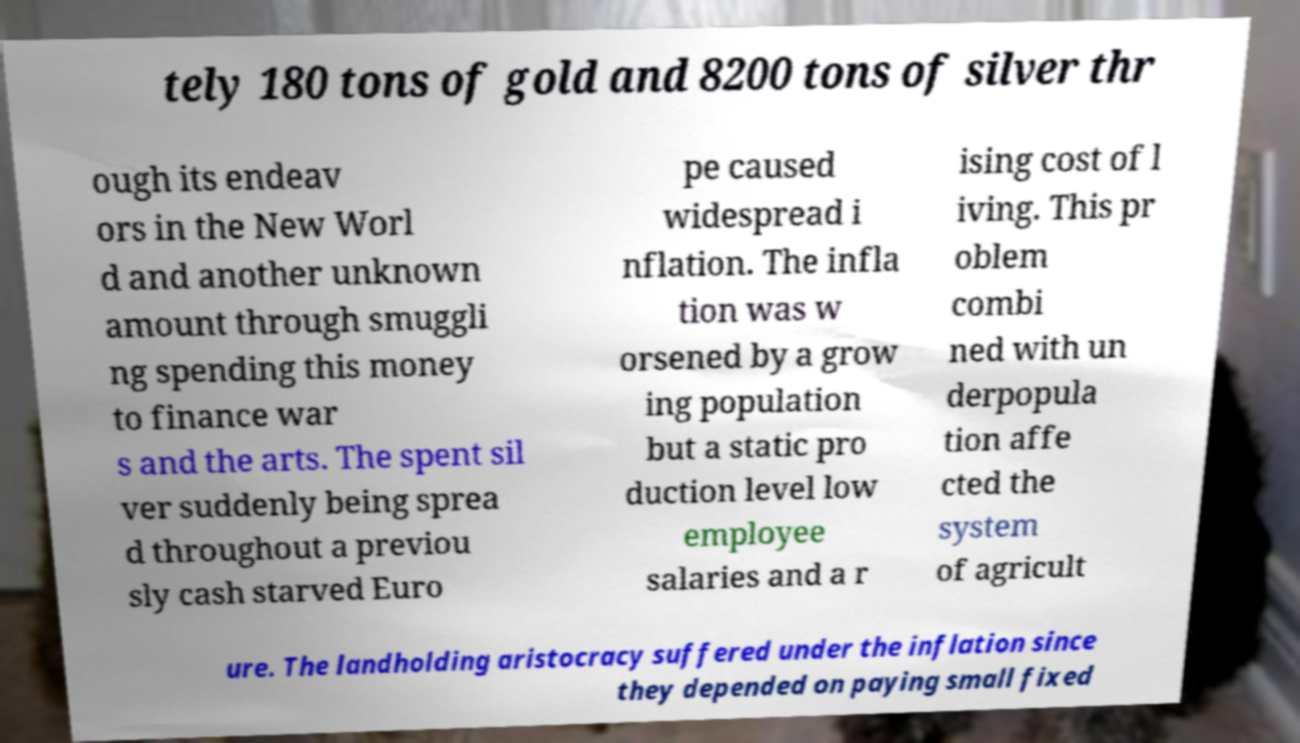For documentation purposes, I need the text within this image transcribed. Could you provide that? tely 180 tons of gold and 8200 tons of silver thr ough its endeav ors in the New Worl d and another unknown amount through smuggli ng spending this money to finance war s and the arts. The spent sil ver suddenly being sprea d throughout a previou sly cash starved Euro pe caused widespread i nflation. The infla tion was w orsened by a grow ing population but a static pro duction level low employee salaries and a r ising cost of l iving. This pr oblem combi ned with un derpopula tion affe cted the system of agricult ure. The landholding aristocracy suffered under the inflation since they depended on paying small fixed 